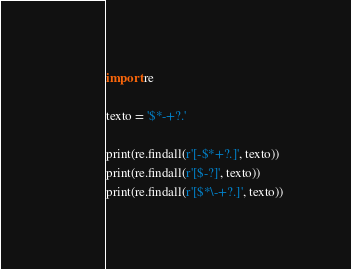Convert code to text. <code><loc_0><loc_0><loc_500><loc_500><_Python_>import re

texto = '$*-+?.'

print(re.findall(r'[-$*+?.]', texto))
print(re.findall(r'[$-?]', texto))
print(re.findall(r'[$*\-+?.]', texto))</code> 